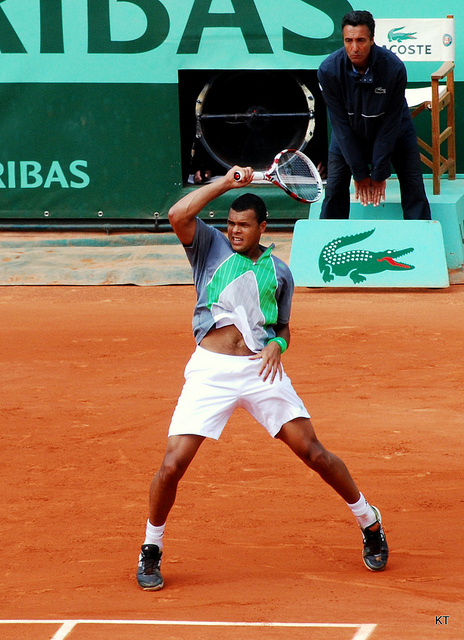Describe the atmosphere of the match as suggested by the image. From the image, the atmosphere appears focused and competitive. The player's expression is one of intense concentration, suggesting the stakes of the match could be high. The presence of branding and lack of visible audience hint that the match may be part of a larger, well-sponsored tournament. The clay court surface also suggests that this could be a significant match, possibly part of a clay-court season, often characterized by events leading up to the French Open. 